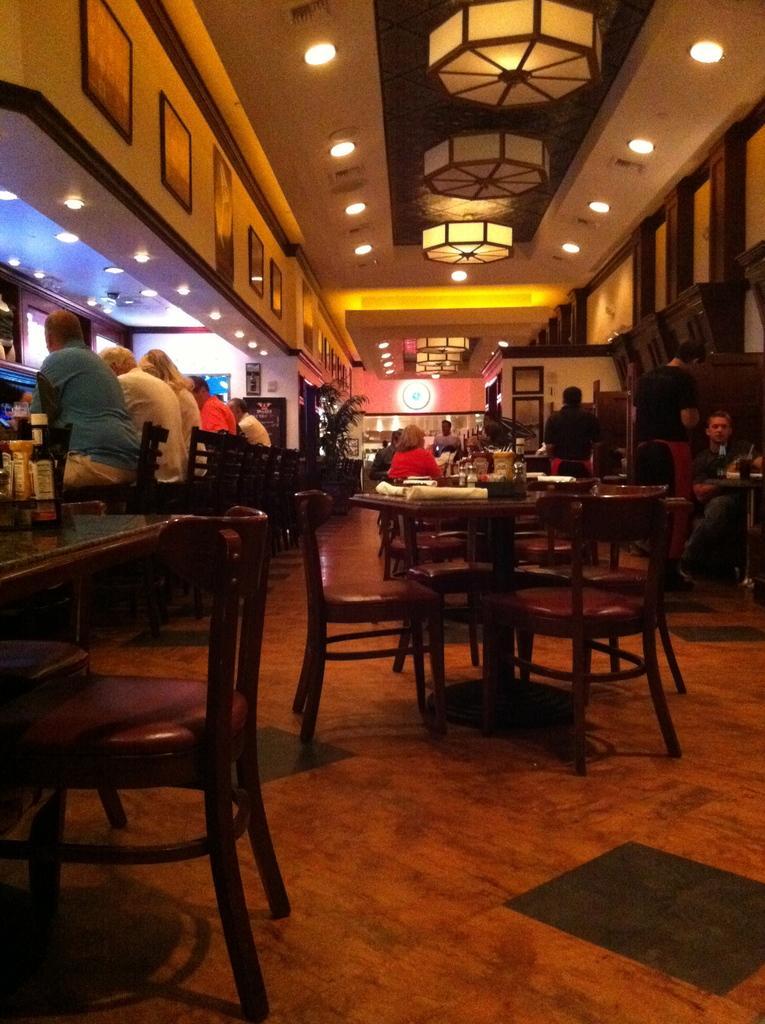Please provide a concise description of this image. At the top we can see ceiling and lights. We can see persons sitting on chairs. There are tables. This is a floor. 